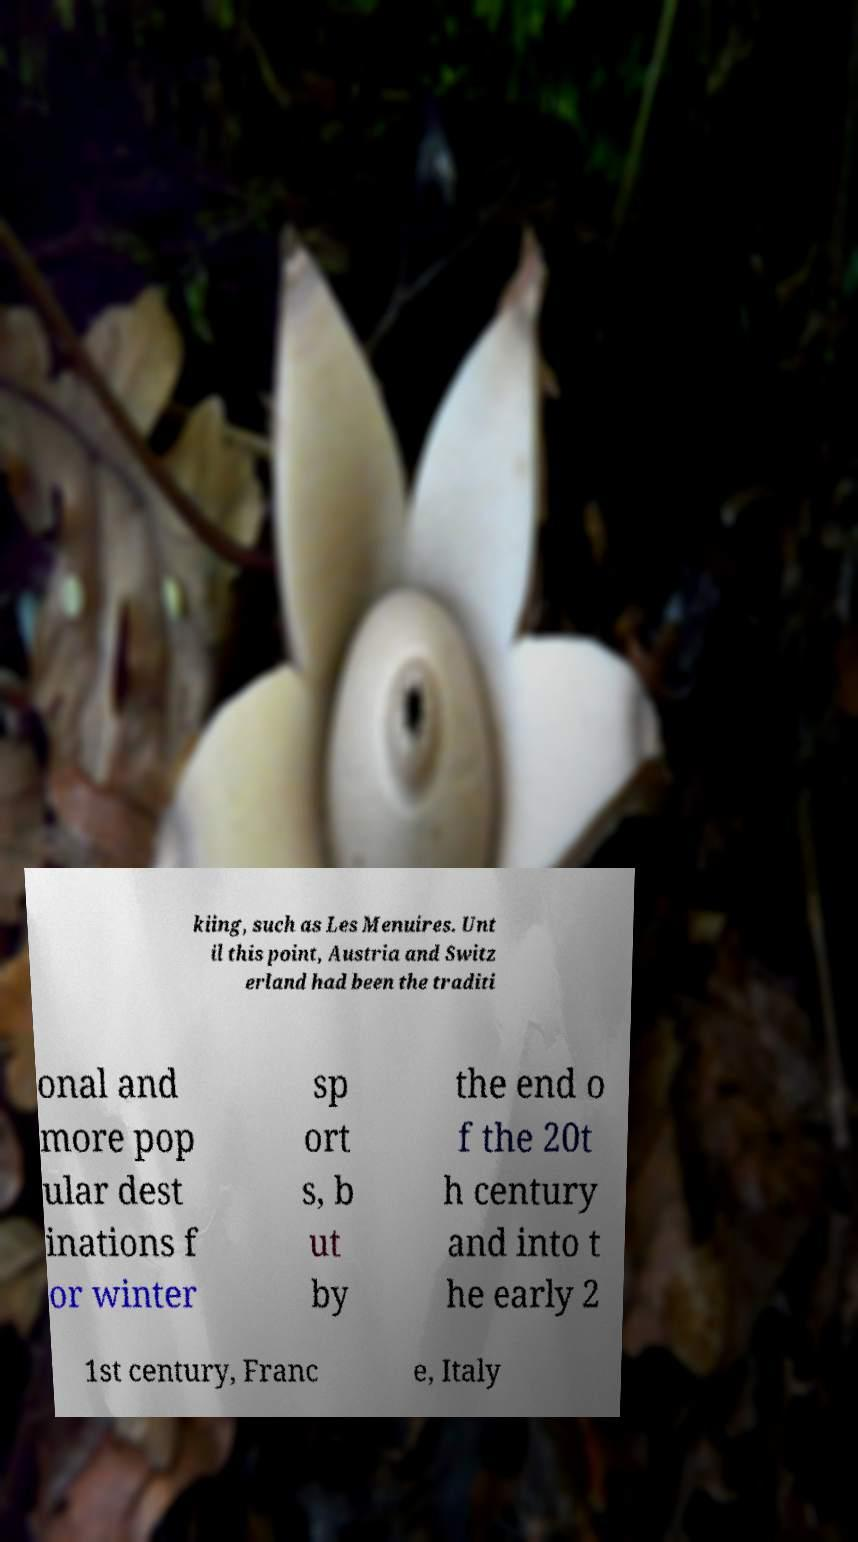What messages or text are displayed in this image? I need them in a readable, typed format. kiing, such as Les Menuires. Unt il this point, Austria and Switz erland had been the traditi onal and more pop ular dest inations f or winter sp ort s, b ut by the end o f the 20t h century and into t he early 2 1st century, Franc e, Italy 